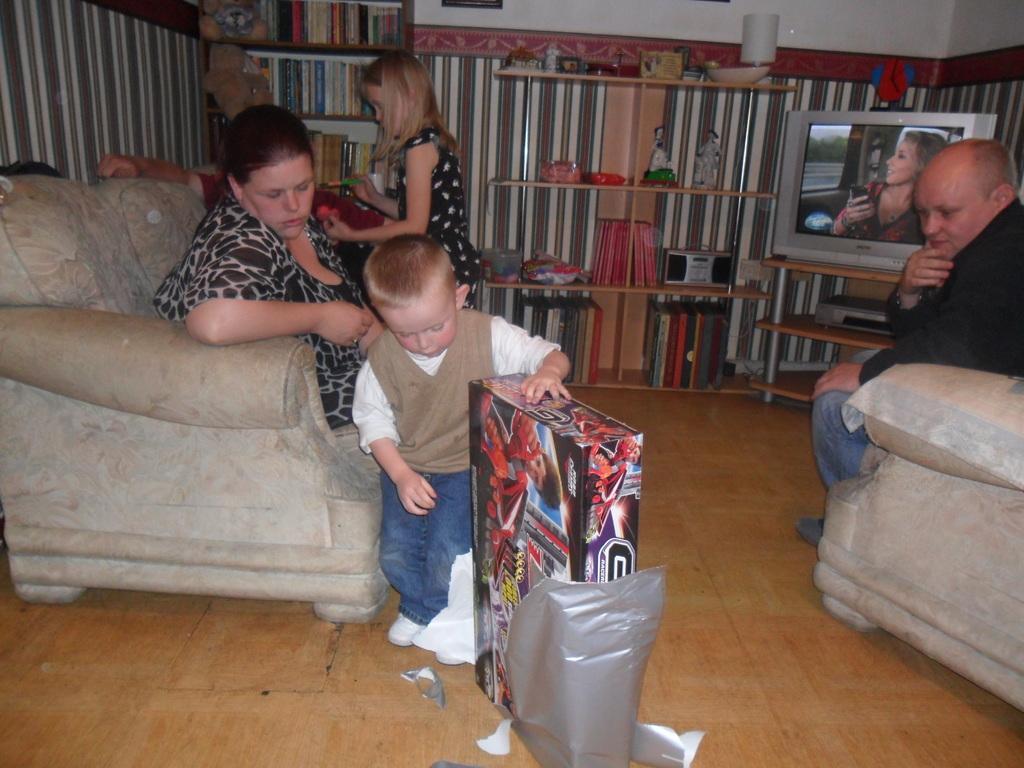Describe this image in one or two sentences. In this image we can see a man and a woman sitting in the sofas and a boy standing on the floor holding a box with a wrapper. On the backside we can see some statues, a lamp, toys tape recorder and some objects placed in the shelves. We can also see a group of books in the racks, a television on the stand, some teddy bears and a girl standing holding some objects. 